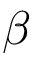Convert formula to latex. <formula><loc_0><loc_0><loc_500><loc_500>\beta</formula> 